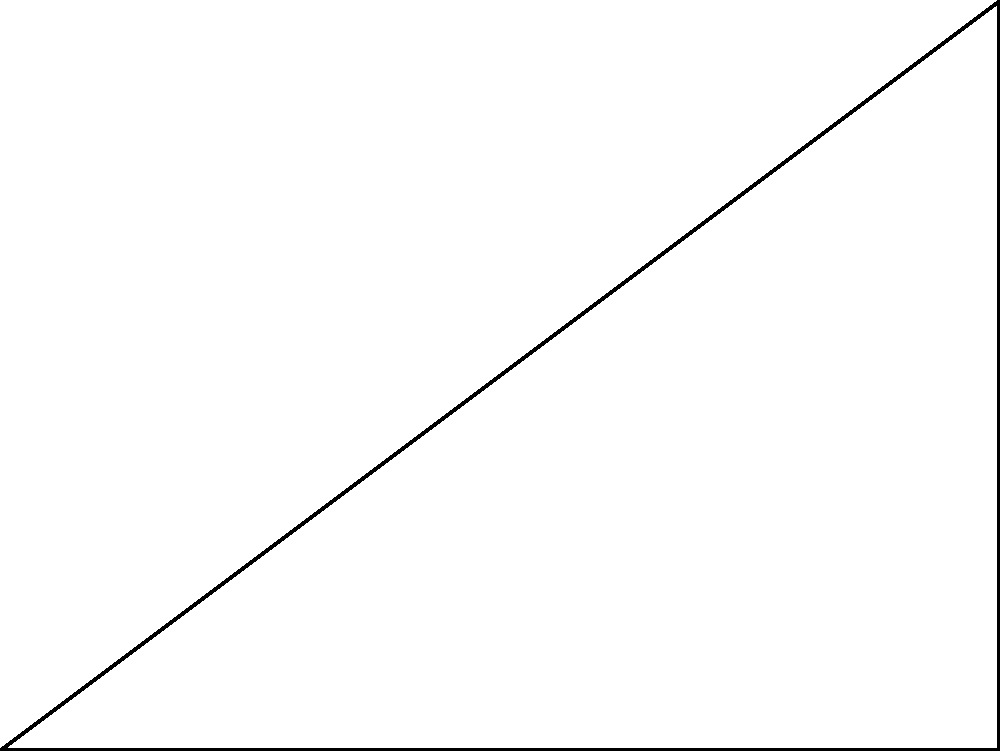A robotic arm is designed to reach point B from its base at point O. The arm can rotate around point O and has a fixed length of 5 cm. If the coordinates of point B are (4 cm, 3 cm) relative to O, what is the optimal angle $\theta$ (in degrees) that the arm should rotate to reach point B? To solve this problem, we can use trigonometry. Let's approach this step-by-step:

1) First, we need to recognize that we have a right triangle OAB, where:
   - OA is the horizontal distance (4 cm)
   - AB is the vertical distance (3 cm)
   - OB is the length of the robotic arm (5 cm)

2) We're looking for the angle $\theta$ between OA and OB.

3) We can use the arctangent function (atan or tan^(-1)) to find this angle:

   $$\theta = \tan^{-1}(\frac{\text{opposite}}{\text{adjacent}}) = \tan^{-1}(\frac{AB}{OA})$$

4) Substituting our values:

   $$\theta = \tan^{-1}(\frac{3}{4})$$

5) Using a calculator or programming function to evaluate this:

   $$\theta \approx 36.87°$$

6) Round to two decimal places for precision.

Therefore, the optimal angle for the robotic arm to reach point B is approximately 36.87°.
Answer: $36.87°$ 